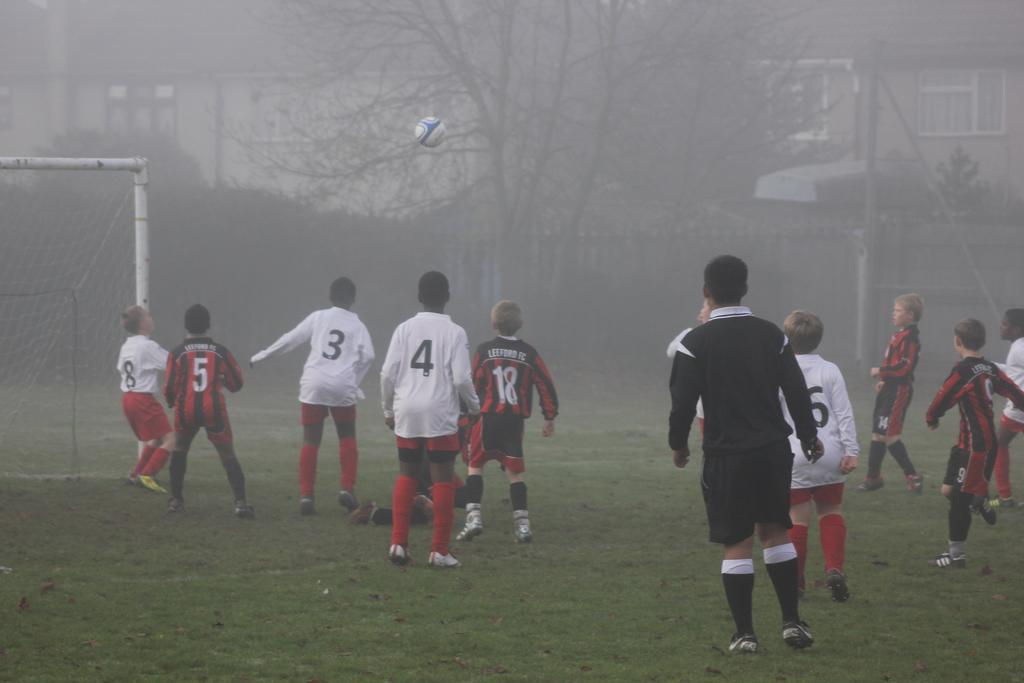<image>
Create a compact narrative representing the image presented. Children soccer players from the Lefford FC are playing soccer on a foggy day. 